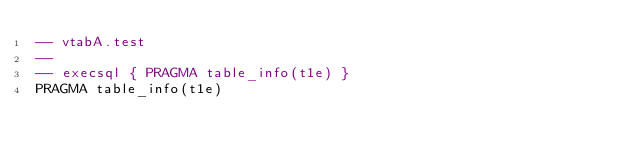Convert code to text. <code><loc_0><loc_0><loc_500><loc_500><_SQL_>-- vtabA.test
-- 
-- execsql { PRAGMA table_info(t1e) }
PRAGMA table_info(t1e)</code> 